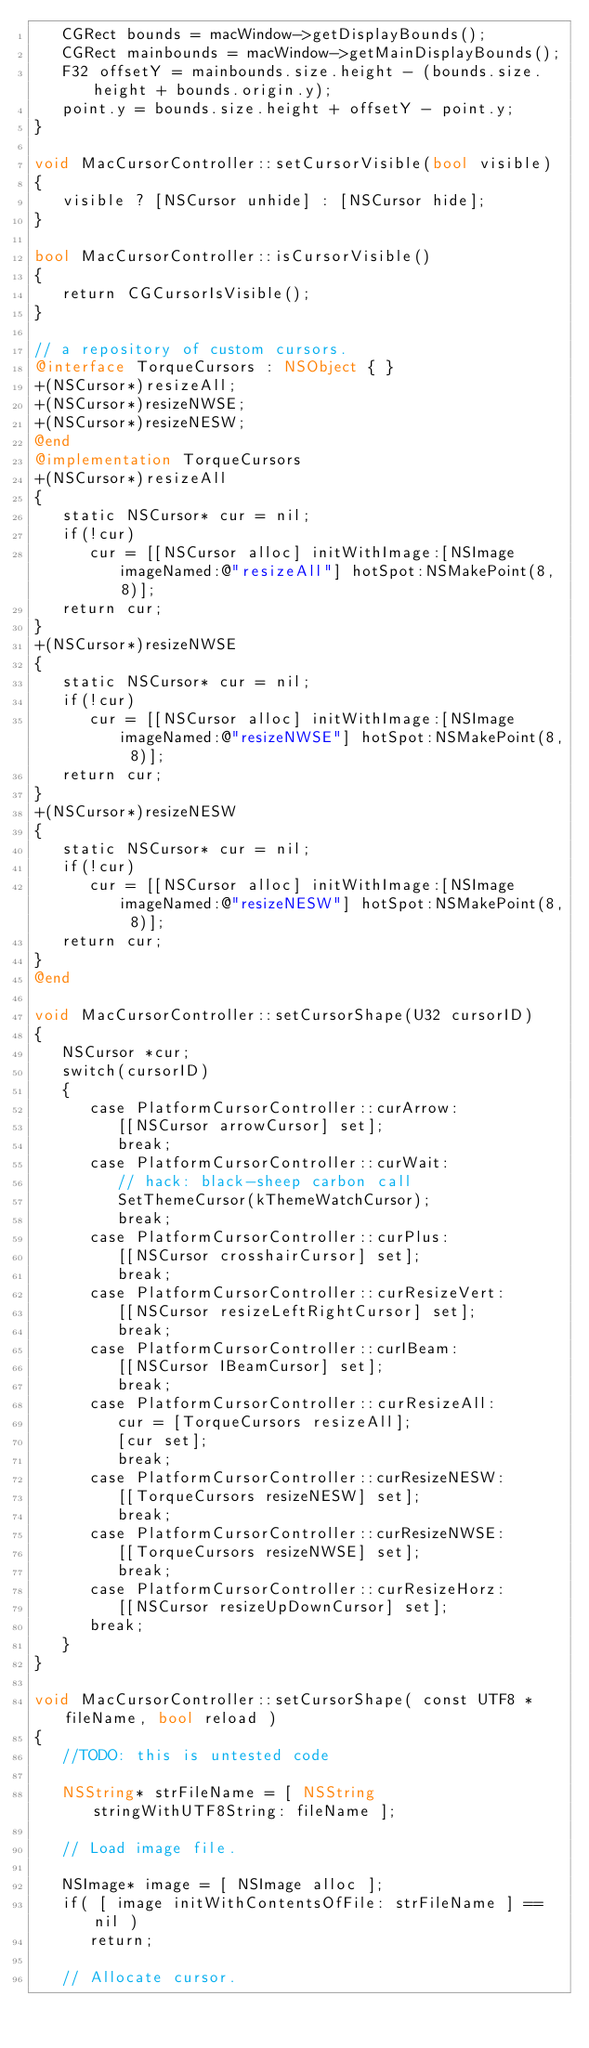<code> <loc_0><loc_0><loc_500><loc_500><_ObjectiveC_>   CGRect bounds = macWindow->getDisplayBounds();
   CGRect mainbounds = macWindow->getMainDisplayBounds();
   F32 offsetY = mainbounds.size.height - (bounds.size.height + bounds.origin.y);
   point.y = bounds.size.height + offsetY - point.y;
}

void MacCursorController::setCursorVisible(bool visible)
{
   visible ? [NSCursor unhide] : [NSCursor hide];
}

bool MacCursorController::isCursorVisible()
{
   return CGCursorIsVisible();
}

// a repository of custom cursors.
@interface TorqueCursors : NSObject { }
+(NSCursor*)resizeAll;
+(NSCursor*)resizeNWSE;
+(NSCursor*)resizeNESW;
@end
@implementation TorqueCursors
+(NSCursor*)resizeAll
{
   static NSCursor* cur = nil;
   if(!cur)
      cur = [[NSCursor alloc] initWithImage:[NSImage imageNamed:@"resizeAll"] hotSpot:NSMakePoint(8, 8)];
   return cur;
}
+(NSCursor*)resizeNWSE
{
   static NSCursor* cur = nil;
   if(!cur)
      cur = [[NSCursor alloc] initWithImage:[NSImage imageNamed:@"resizeNWSE"] hotSpot:NSMakePoint(8, 8)];
   return cur;
}
+(NSCursor*)resizeNESW
{
   static NSCursor* cur = nil;
   if(!cur)
      cur = [[NSCursor alloc] initWithImage:[NSImage imageNamed:@"resizeNESW"] hotSpot:NSMakePoint(8, 8)];
   return cur;
}
@end

void MacCursorController::setCursorShape(U32 cursorID)
{
   NSCursor *cur;
   switch(cursorID)
   {
      case PlatformCursorController::curArrow:
         [[NSCursor arrowCursor] set];
         break;
      case PlatformCursorController::curWait:
         // hack: black-sheep carbon call
         SetThemeCursor(kThemeWatchCursor);
         break;
      case PlatformCursorController::curPlus:
         [[NSCursor crosshairCursor] set];
         break;
      case PlatformCursorController::curResizeVert:
         [[NSCursor resizeLeftRightCursor] set];
         break;
      case PlatformCursorController::curIBeam:
         [[NSCursor IBeamCursor] set];
         break;
      case PlatformCursorController::curResizeAll:
         cur = [TorqueCursors resizeAll];
         [cur set];
         break;
      case PlatformCursorController::curResizeNESW:
         [[TorqueCursors resizeNESW] set];
         break;
      case PlatformCursorController::curResizeNWSE:
         [[TorqueCursors resizeNWSE] set];
         break;
      case PlatformCursorController::curResizeHorz:
         [[NSCursor resizeUpDownCursor] set];
      break;
   }
}

void MacCursorController::setCursorShape( const UTF8 *fileName, bool reload )
{
   //TODO: this is untested code
   
   NSString* strFileName = [ NSString stringWithUTF8String: fileName ];
   
   // Load image file.
   
   NSImage* image = [ NSImage alloc ];
   if( [ image initWithContentsOfFile: strFileName ] == nil )
      return;

   // Allocate cursor.
   </code> 